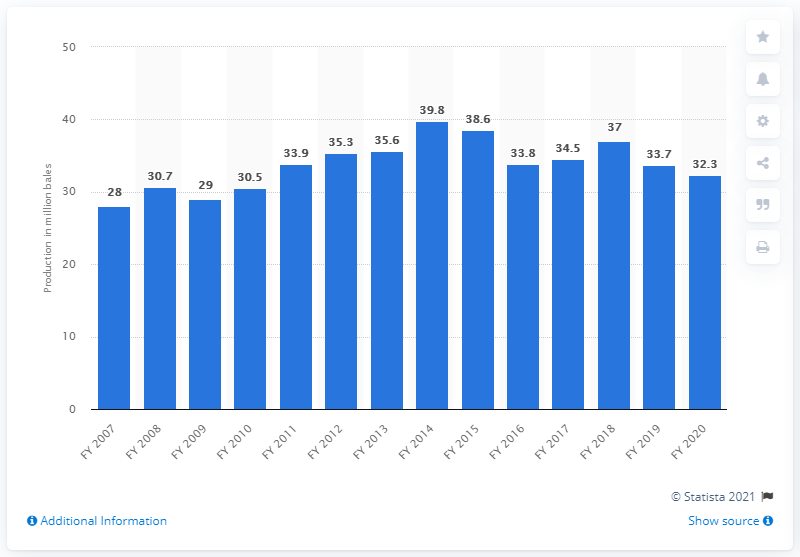Give some essential details in this illustration. In 2019, a total of 33.7 million bales of cotton were produced in India. 